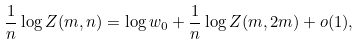<formula> <loc_0><loc_0><loc_500><loc_500>\frac { 1 } { n } \log Z ( m , n ) = \log w _ { 0 } + \frac { 1 } { n } \log Z ( m , 2 m ) + o ( 1 ) ,</formula> 